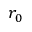Convert formula to latex. <formula><loc_0><loc_0><loc_500><loc_500>r _ { 0 }</formula> 